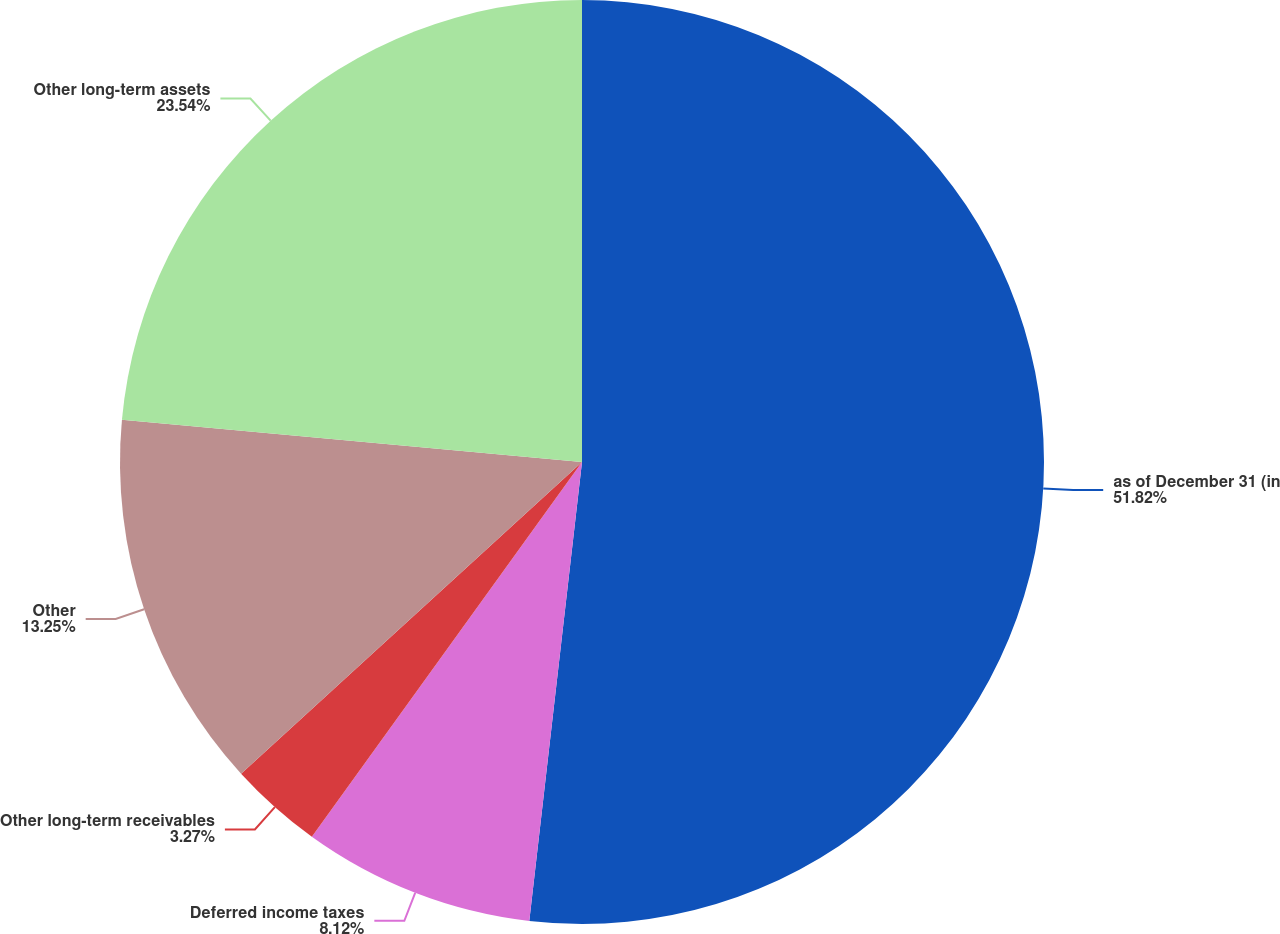<chart> <loc_0><loc_0><loc_500><loc_500><pie_chart><fcel>as of December 31 (in<fcel>Deferred income taxes<fcel>Other long-term receivables<fcel>Other<fcel>Other long-term assets<nl><fcel>51.82%<fcel>8.12%<fcel>3.27%<fcel>13.25%<fcel>23.54%<nl></chart> 